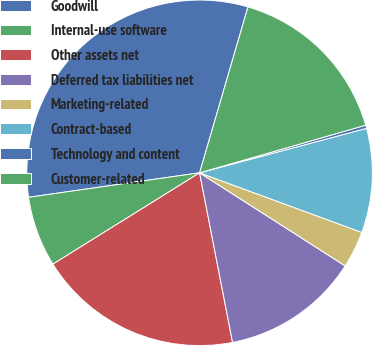Convert chart. <chart><loc_0><loc_0><loc_500><loc_500><pie_chart><fcel>Goodwill<fcel>Internal-use software<fcel>Other assets net<fcel>Deferred tax liabilities net<fcel>Marketing-related<fcel>Contract-based<fcel>Technology and content<fcel>Customer-related<nl><fcel>31.78%<fcel>6.6%<fcel>19.19%<fcel>12.89%<fcel>3.45%<fcel>9.75%<fcel>0.3%<fcel>16.04%<nl></chart> 